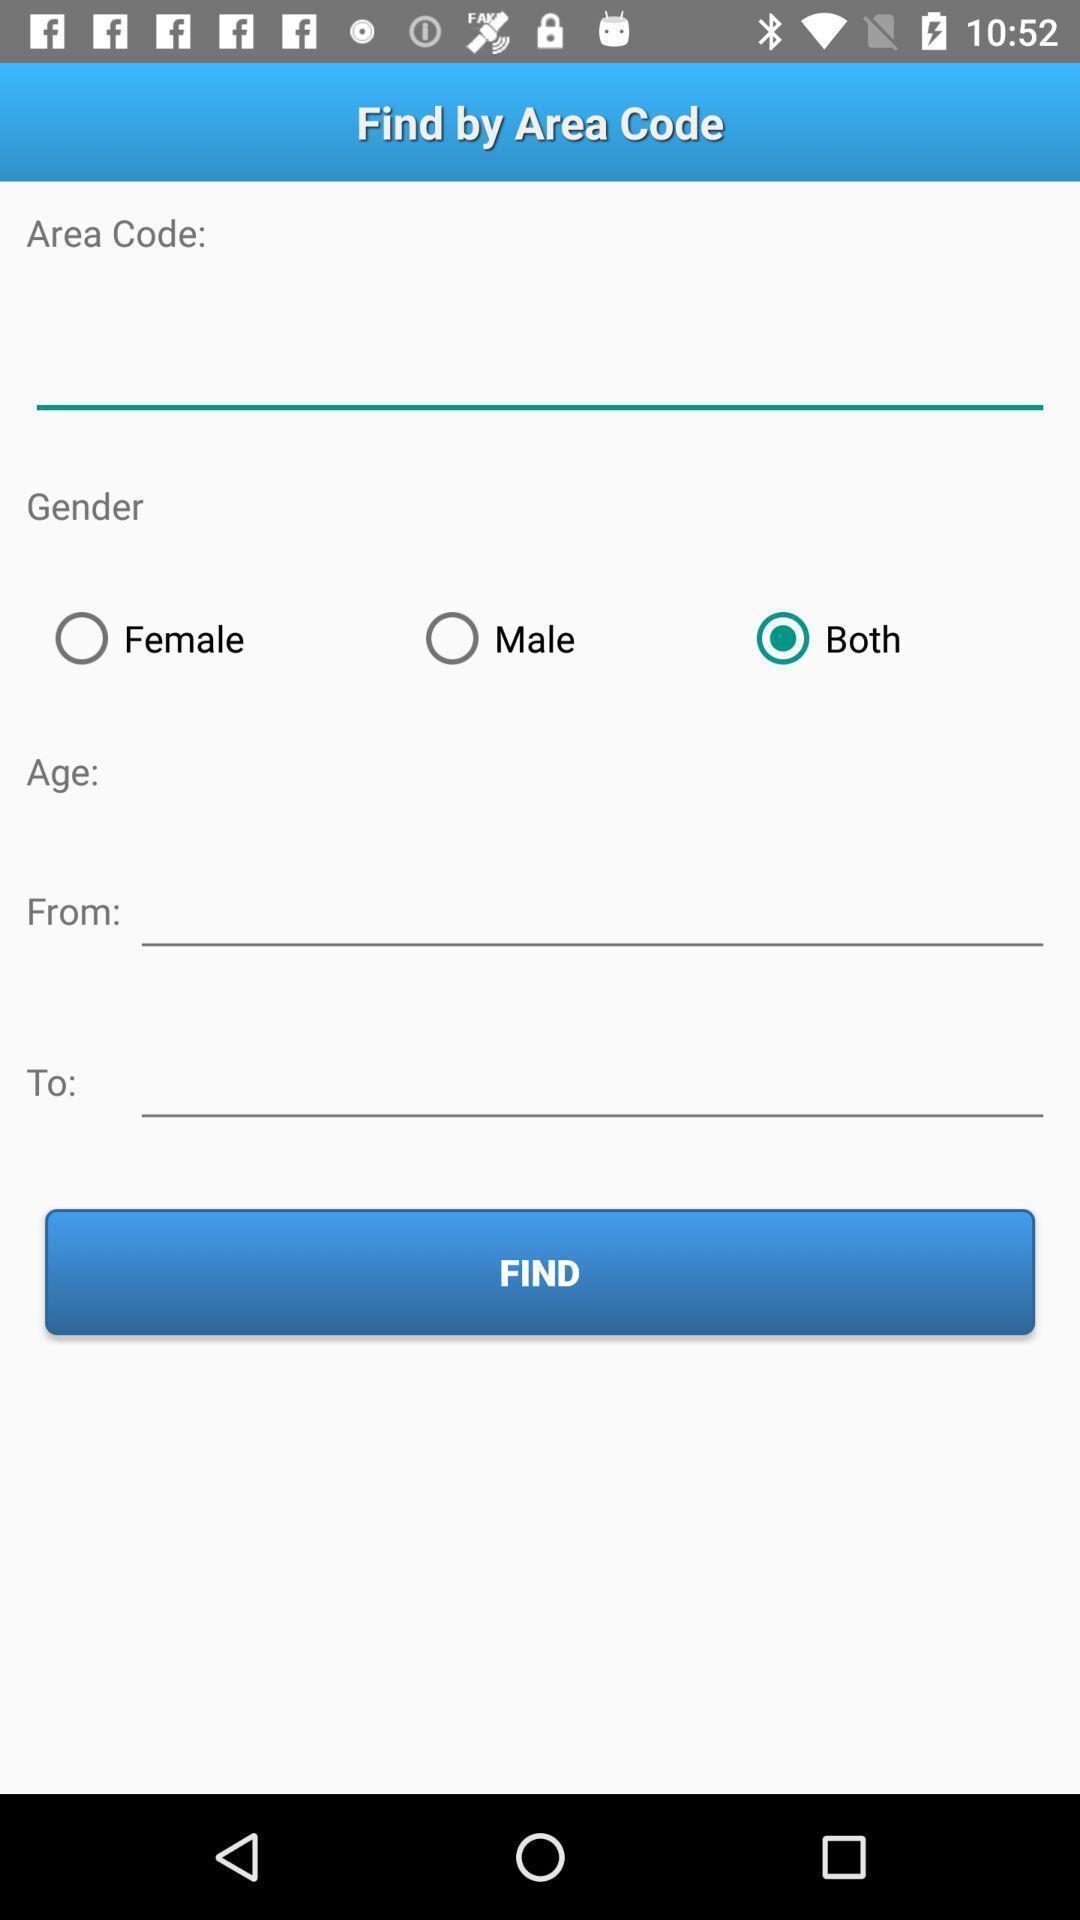Summarize the main components in this picture. Screen displaying blanks to fill. 